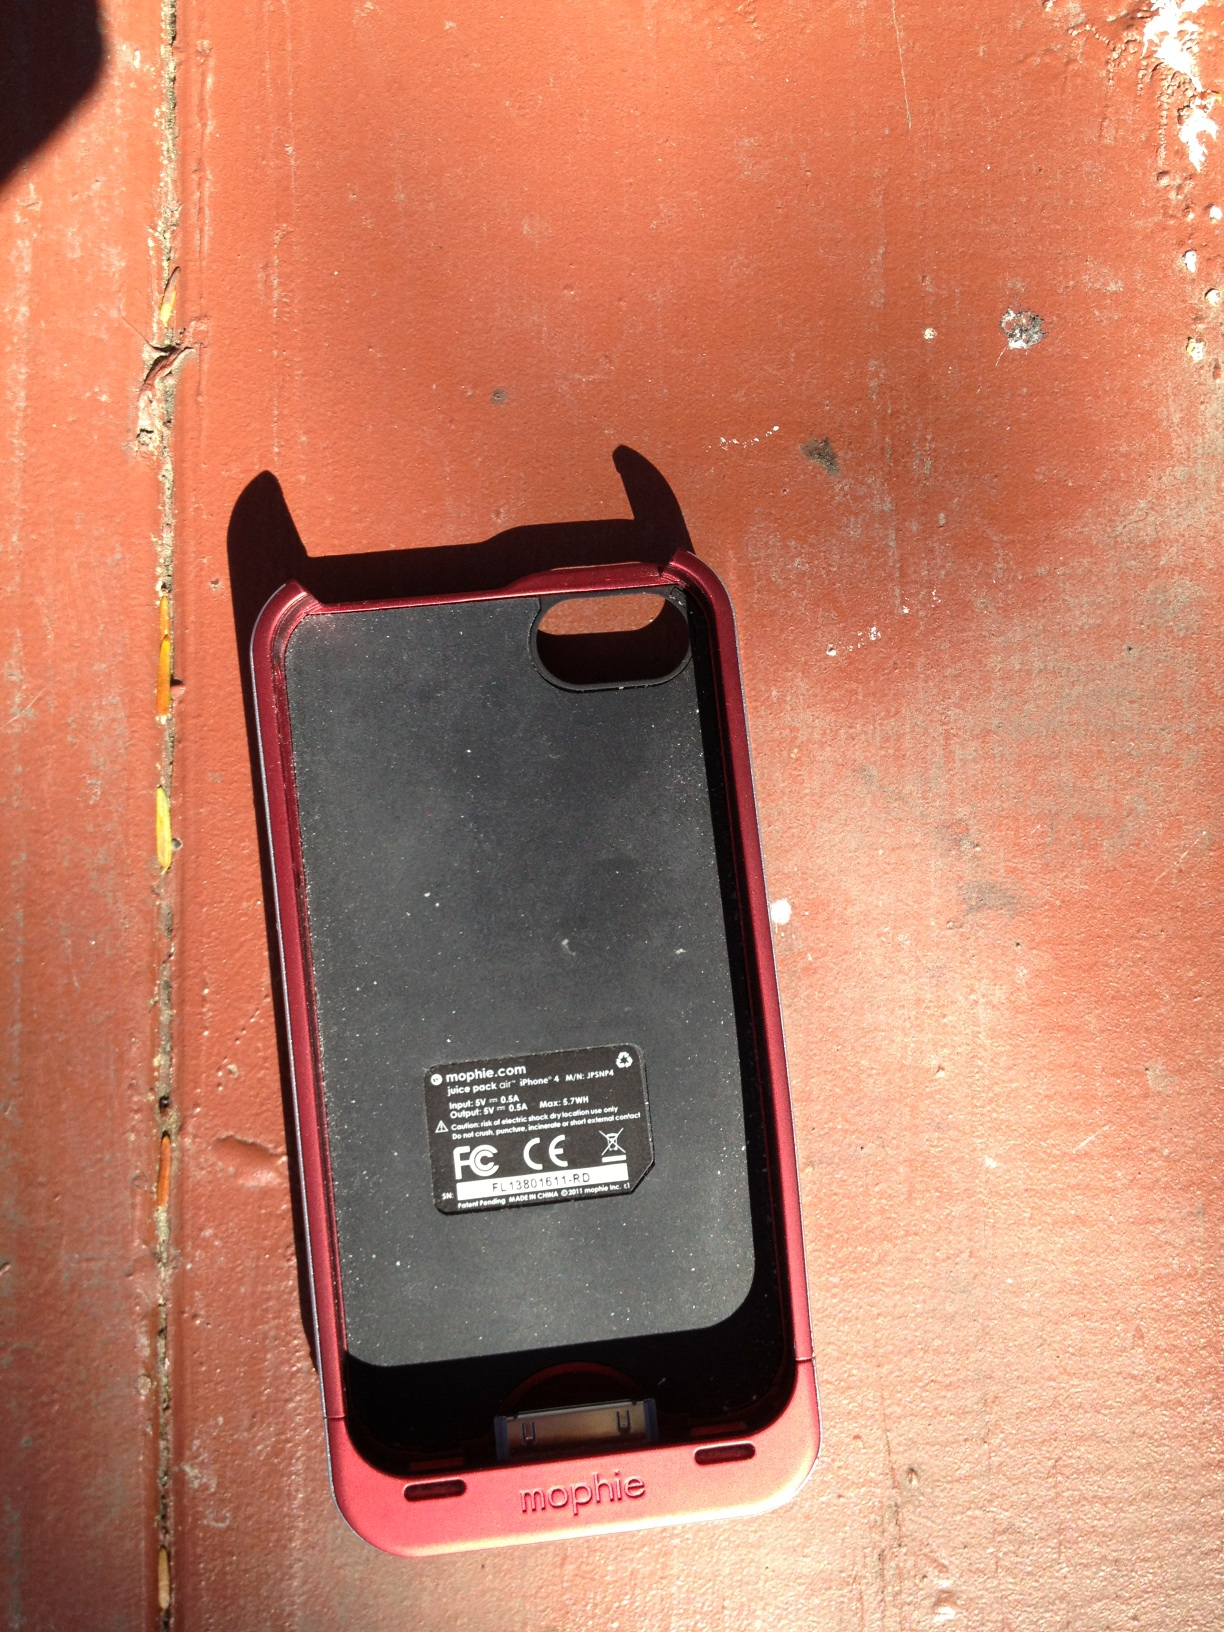How does this type of phone case benefit a smartphone user? A Mophie battery pack case benefits smartphone users by offering additional battery life, which can be crucial when access to power for recharging isn't readily available. It also serves as protection against physical damage to the phone. 